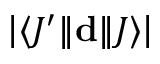Convert formula to latex. <formula><loc_0><loc_0><loc_500><loc_500>\left | \langle J ^ { \prime } | \, | d | \, | J \rangle \right |</formula> 